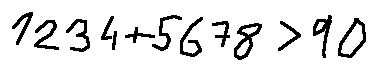Convert formula to latex. <formula><loc_0><loc_0><loc_500><loc_500>1 2 3 4 + 5 6 7 8 > 9 0</formula> 